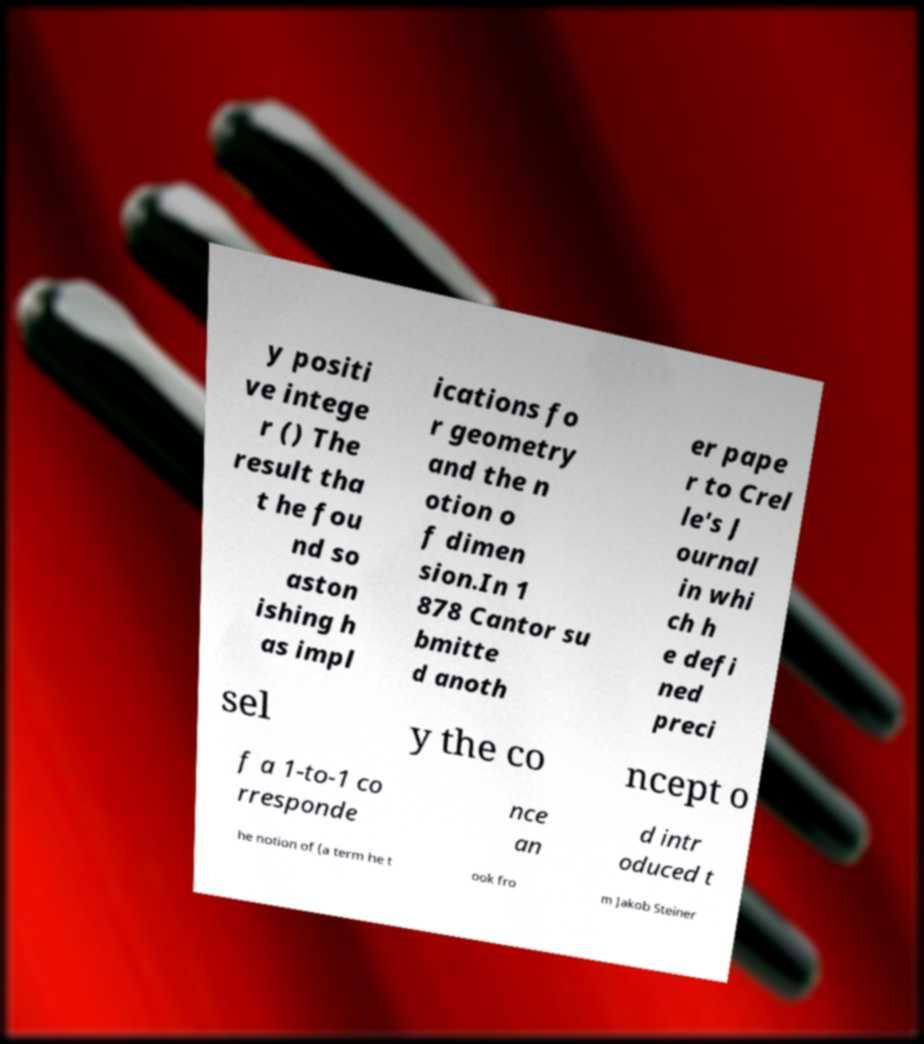There's text embedded in this image that I need extracted. Can you transcribe it verbatim? y positi ve intege r () The result tha t he fou nd so aston ishing h as impl ications fo r geometry and the n otion o f dimen sion.In 1 878 Cantor su bmitte d anoth er pape r to Crel le's J ournal in whi ch h e defi ned preci sel y the co ncept o f a 1-to-1 co rresponde nce an d intr oduced t he notion of (a term he t ook fro m Jakob Steiner 